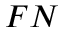<formula> <loc_0><loc_0><loc_500><loc_500>F N</formula> 